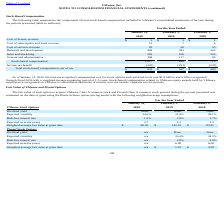According to Vmware's financial document, What was the total unrecognized compensation cost for stock options and restricted stock as of 2020? According to the financial document, $1.8 billion. The relevant text states: "on cost for stock options and restricted stock was $1.8 billion and will be recognized..." Also, Which years does the table provide information for  the components of total stock-based compensation included in VMware’s consolidated statements of income? The document contains multiple relevant values: 2020, 2019, 2018. From the document: "2020 2019 2018 2020 2019 2018 2020 2019 2018..." Also, What was the cost of license revenue in 2018? According to the financial document, 2 (in millions). The relevant text states: "January 31, February 1, February 2,..." Additionally, Which years did Stock-based compensation exceed $1,000 million? According to the financial document, 2020. The relevant text states: "2020 2019 2018..." Also, can you calculate: What was the change in the Cost of subscription and SaaS revenue between 2018 and 2019? Based on the calculation: 7-5, the result is 2 (in millions). This is based on the information: "Cost of subscription and SaaS revenue 13 7 5 Cost of subscription and SaaS revenue 13 7 5..." The key data points involved are: 5, 7. Also, can you calculate: What was the percentage change in Total stock-based compensation, net of tax between 2019 and 2020? To answer this question, I need to perform calculations using the financial data. The calculation is: (670-547)/547, which equals 22.49 (percentage). This is based on the information: "otal stock-based compensation, net of tax $ 670 $ 547 $ 480 Total stock-based compensation, net of tax $ 670 $ 547 $ 480..." The key data points involved are: 547, 670. 